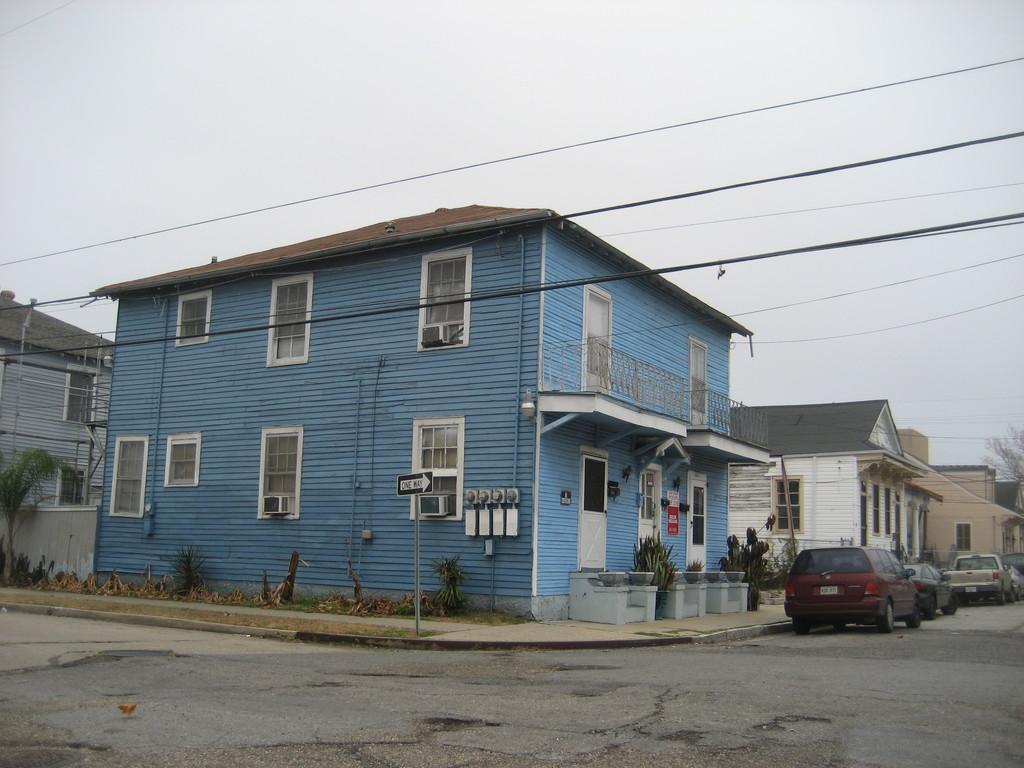How would you summarize this image in a sentence or two? This picture is clicked outside. In the center we can see the houses and we can see the windows of the houses and we can see the plants, vehicles and some other objects. In the background we can see the sky and the cables and some other objects. 